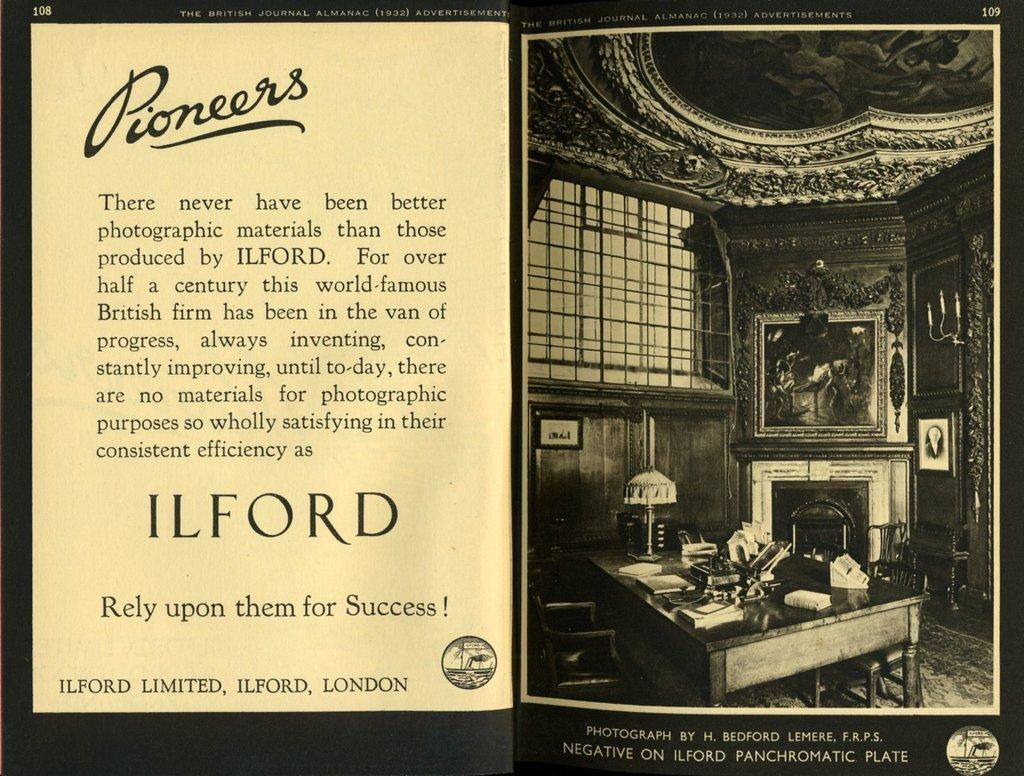Provide a one-sentence caption for the provided image. An advertisement for a photography company named Pioneers. 